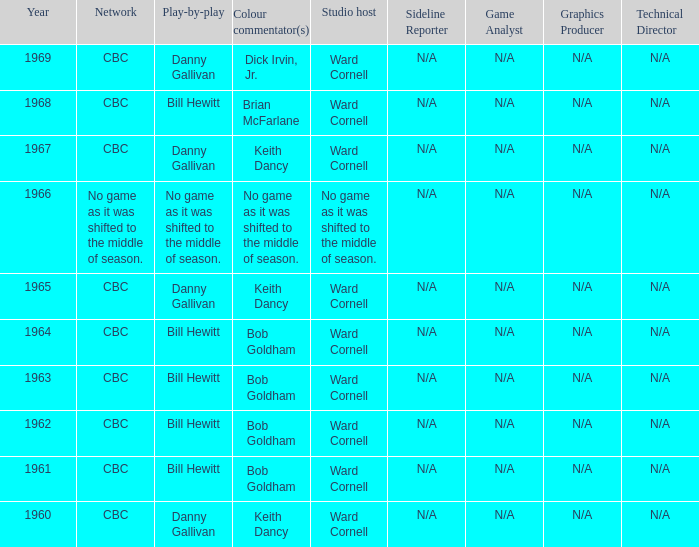Who gave the play by play commentary with studio host Ward Cornell? Danny Gallivan, Bill Hewitt, Danny Gallivan, Danny Gallivan, Bill Hewitt, Bill Hewitt, Bill Hewitt, Bill Hewitt, Danny Gallivan. 